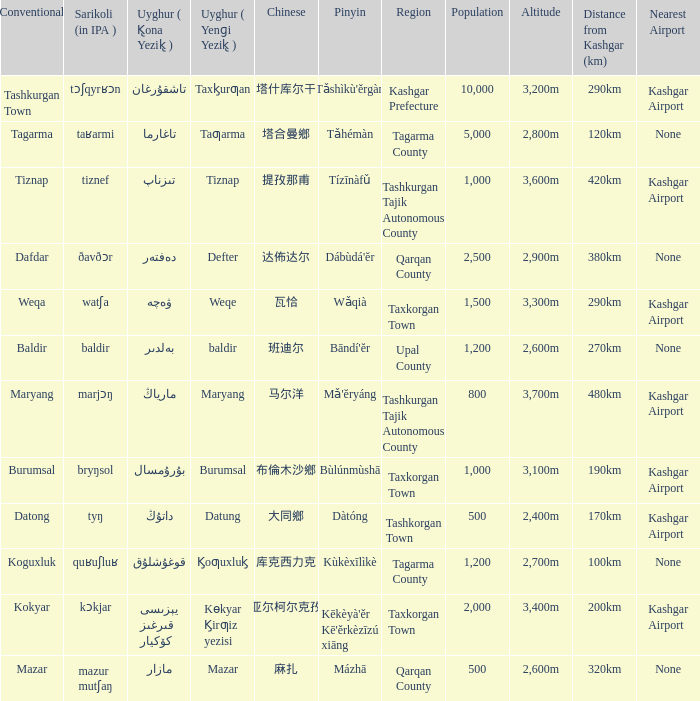Can you parse all the data within this table? {'header': ['Conventional', 'Sarikoli (in IPA )', 'Uyghur ( K̢ona Yezik̢ )', 'Uyghur ( Yenɡi Yezik̢ )', 'Chinese', 'Pinyin', 'Region', 'Population', 'Altitude', 'Distance from Kashgar (km)', 'Nearest Airport'], 'rows': [['Tashkurgan Town', 'tɔʃqyrʁɔn', 'تاشقۇرغان', 'Taxk̡urƣan', '塔什库尔干', "Tǎshìkù'ěrgàn", 'Kashgar Prefecture', '10,000', '3,200m', '290km', 'Kashgar Airport'], ['Tagarma', 'taʁarmi', 'تاغارما', 'Taƣarma', '塔合曼鄉', 'Tǎhémàn', 'Tagarma County', '5,000', '2,800m', '120km', 'None'], ['Tiznap', 'tiznef', 'تىزناپ', 'Tiznap', '提孜那甫', 'Tízīnàfǔ', 'Tashkurgan Tajik Autonomous County', '1,000', '3,600m', '420km', 'Kashgar Airport'], ['Dafdar', 'ðavðɔr', 'دەفتەر', 'Defter', '达佈达尔', "Dábùdá'ĕr", 'Qarqan County', '2,500', '2,900m', '380km', 'None'], ['Weqa', 'watʃa', 'ۋەچە', 'Weqe', '瓦恰', 'Wǎqià', 'Taxkorgan Town', '1,500', '3,300m', '290km', 'Kashgar Airport'], ['Baldir', 'baldir', 'بەلدىر', 'baldir', '班迪尔', "Bāndí'ĕr", 'Upal County', '1,200', '2,600m', '270km', 'None'], ['Maryang', 'marjɔŋ', 'مارياڭ', 'Maryang', '马尔洋', "Mǎ'ĕryáng", 'Tashkurgan Tajik Autonomous County', '800', '3,700m', '480km', 'Kashgar Airport'], ['Burumsal', 'bryŋsol', 'بۇرۇمسال', 'Burumsal', '布倫木沙鄉', 'Bùlúnmùshā', 'Taxkorgan Town', '1,000', '3,100m', '190km', 'Kashgar Airport'], ['Datong', 'tyŋ', 'داتۇڭ', 'Datung', '大同鄉', 'Dàtóng', 'Tashkorgan Town', '500', '2,400m', '170km', 'Kashgar Airport'], ['Koguxluk', 'quʁuʃluʁ', 'قوغۇشلۇق', 'K̡oƣuxluk̡', '库克西力克', 'Kùkèxīlìkè', 'Tagarma County', '1,200', '2,700m', '100km', 'None'], ['Kokyar', 'kɔkjar', 'كۆكيار قىرغىز يېزىسى', 'Kɵkyar K̡irƣiz yezisi', '科克亚尔柯尔克孜族乡', "Kēkèyà'ěr Kē'ěrkèzīzú xiāng", 'Taxkorgan Town', '2,000', '3,400m', '200km', 'Kashgar Airport'], ['Mazar', 'mazur mutʃaŋ', 'مازار', 'Mazar', '麻扎', 'Mázhā', 'Qarqan County', '500', '2,600m', '320km', 'None']]} Name the pinyin for mazar Mázhā. 